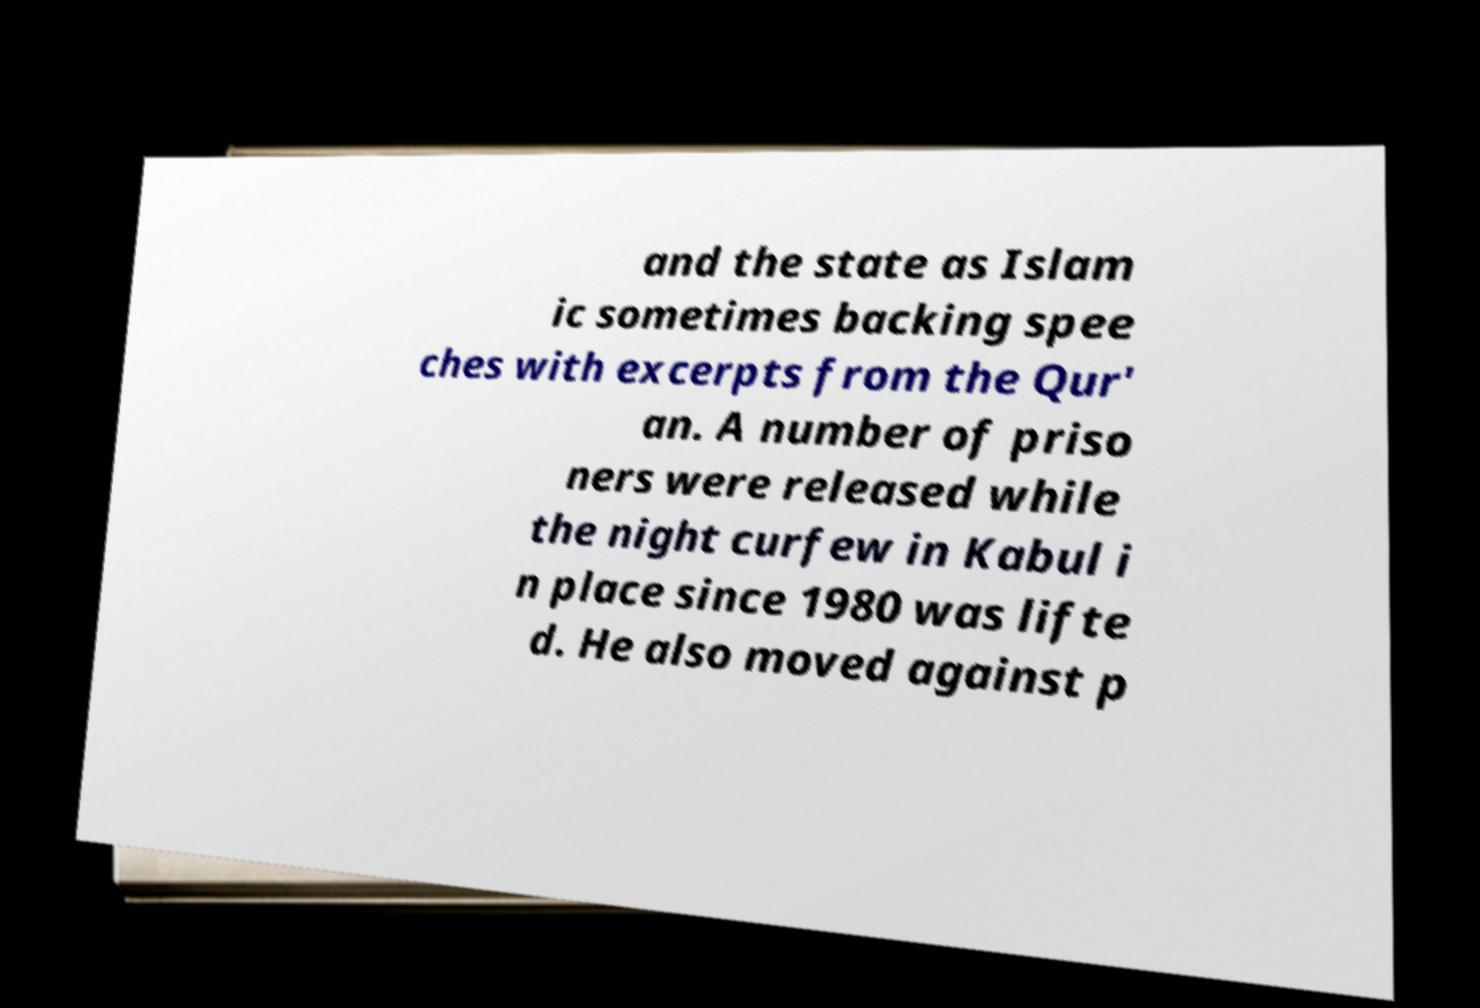For documentation purposes, I need the text within this image transcribed. Could you provide that? and the state as Islam ic sometimes backing spee ches with excerpts from the Qur' an. A number of priso ners were released while the night curfew in Kabul i n place since 1980 was lifte d. He also moved against p 